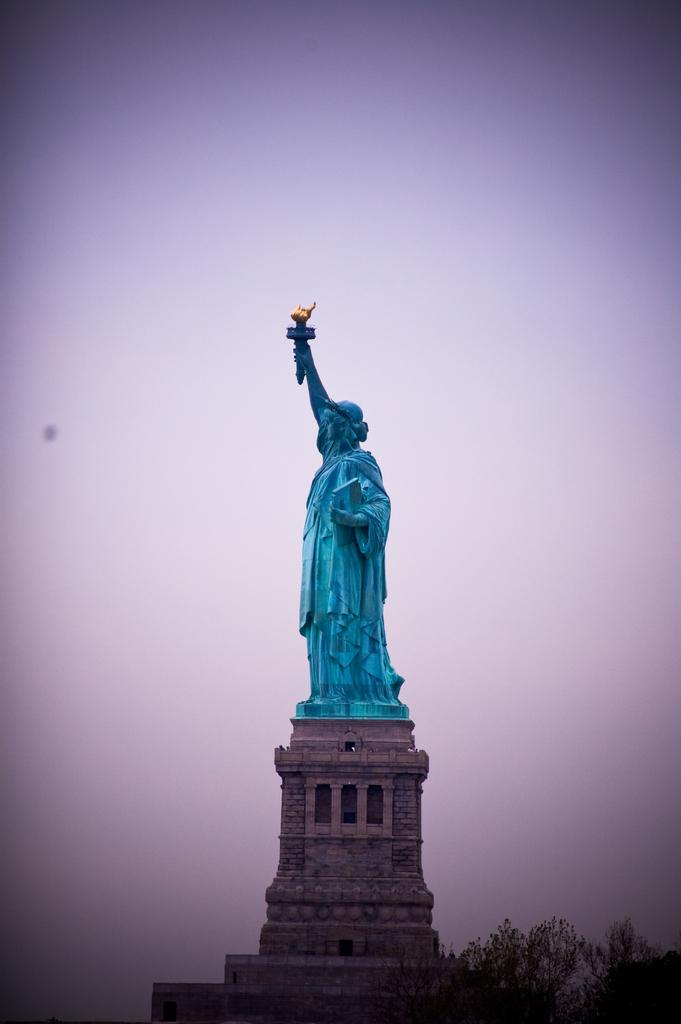What is the main subject of the image? There is a statue of liberty in the image. How is the statue of liberty positioned in the image? The statue of liberty is placed on an object. What type of natural element can be seen in the image? There is a tree in the right bottom corner of the image. Can you tell me how many maids are standing next to the statue of liberty in the image? There are no maids present in the image; it only features the statue of liberty and a tree. 